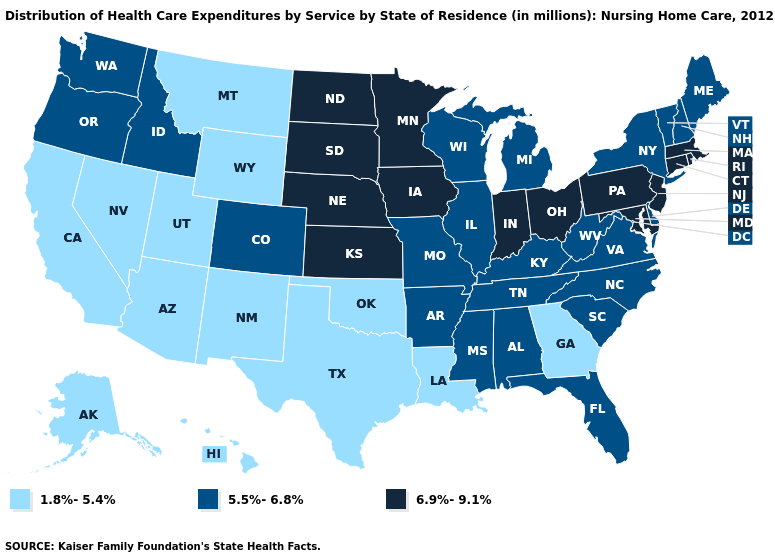Is the legend a continuous bar?
Concise answer only. No. What is the value of Arizona?
Concise answer only. 1.8%-5.4%. Name the states that have a value in the range 5.5%-6.8%?
Quick response, please. Alabama, Arkansas, Colorado, Delaware, Florida, Idaho, Illinois, Kentucky, Maine, Michigan, Mississippi, Missouri, New Hampshire, New York, North Carolina, Oregon, South Carolina, Tennessee, Vermont, Virginia, Washington, West Virginia, Wisconsin. Name the states that have a value in the range 6.9%-9.1%?
Quick response, please. Connecticut, Indiana, Iowa, Kansas, Maryland, Massachusetts, Minnesota, Nebraska, New Jersey, North Dakota, Ohio, Pennsylvania, Rhode Island, South Dakota. Name the states that have a value in the range 6.9%-9.1%?
Be succinct. Connecticut, Indiana, Iowa, Kansas, Maryland, Massachusetts, Minnesota, Nebraska, New Jersey, North Dakota, Ohio, Pennsylvania, Rhode Island, South Dakota. Name the states that have a value in the range 5.5%-6.8%?
Write a very short answer. Alabama, Arkansas, Colorado, Delaware, Florida, Idaho, Illinois, Kentucky, Maine, Michigan, Mississippi, Missouri, New Hampshire, New York, North Carolina, Oregon, South Carolina, Tennessee, Vermont, Virginia, Washington, West Virginia, Wisconsin. Does the first symbol in the legend represent the smallest category?
Short answer required. Yes. Does the first symbol in the legend represent the smallest category?
Be succinct. Yes. Does Texas have the lowest value in the South?
Keep it brief. Yes. What is the highest value in states that border Iowa?
Answer briefly. 6.9%-9.1%. Is the legend a continuous bar?
Keep it brief. No. Name the states that have a value in the range 1.8%-5.4%?
Give a very brief answer. Alaska, Arizona, California, Georgia, Hawaii, Louisiana, Montana, Nevada, New Mexico, Oklahoma, Texas, Utah, Wyoming. Which states hav the highest value in the West?
Keep it brief. Colorado, Idaho, Oregon, Washington. What is the value of Massachusetts?
Answer briefly. 6.9%-9.1%. What is the value of Washington?
Keep it brief. 5.5%-6.8%. 